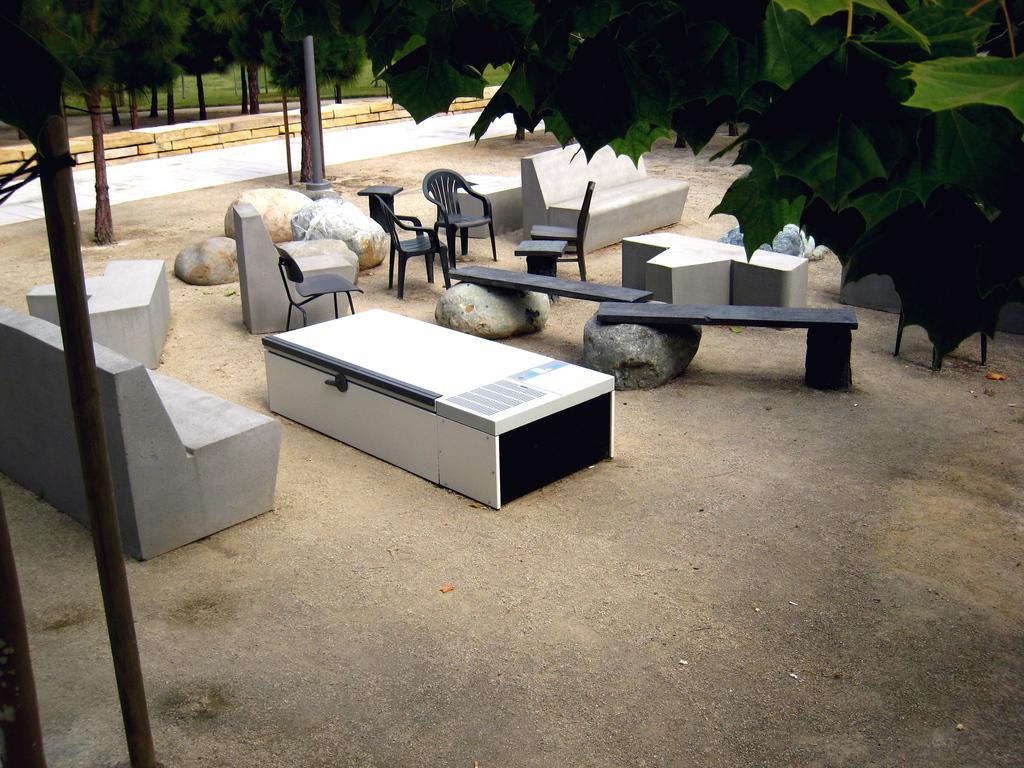What type of objects are placed on the land in the image? There is furniture placed on the land in the image. How are the furniture positioned in relation to the stones? The furniture is placed between stones. Can you identify any specific type of furniture in the image? Yes, there are chairs in the image. What other objects can be seen in the image? There is a pole and trees in the image. Where is the daughter playing in the image? There is no daughter present in the image. What type of desk can be seen in the image? There is no desk present in the image. 